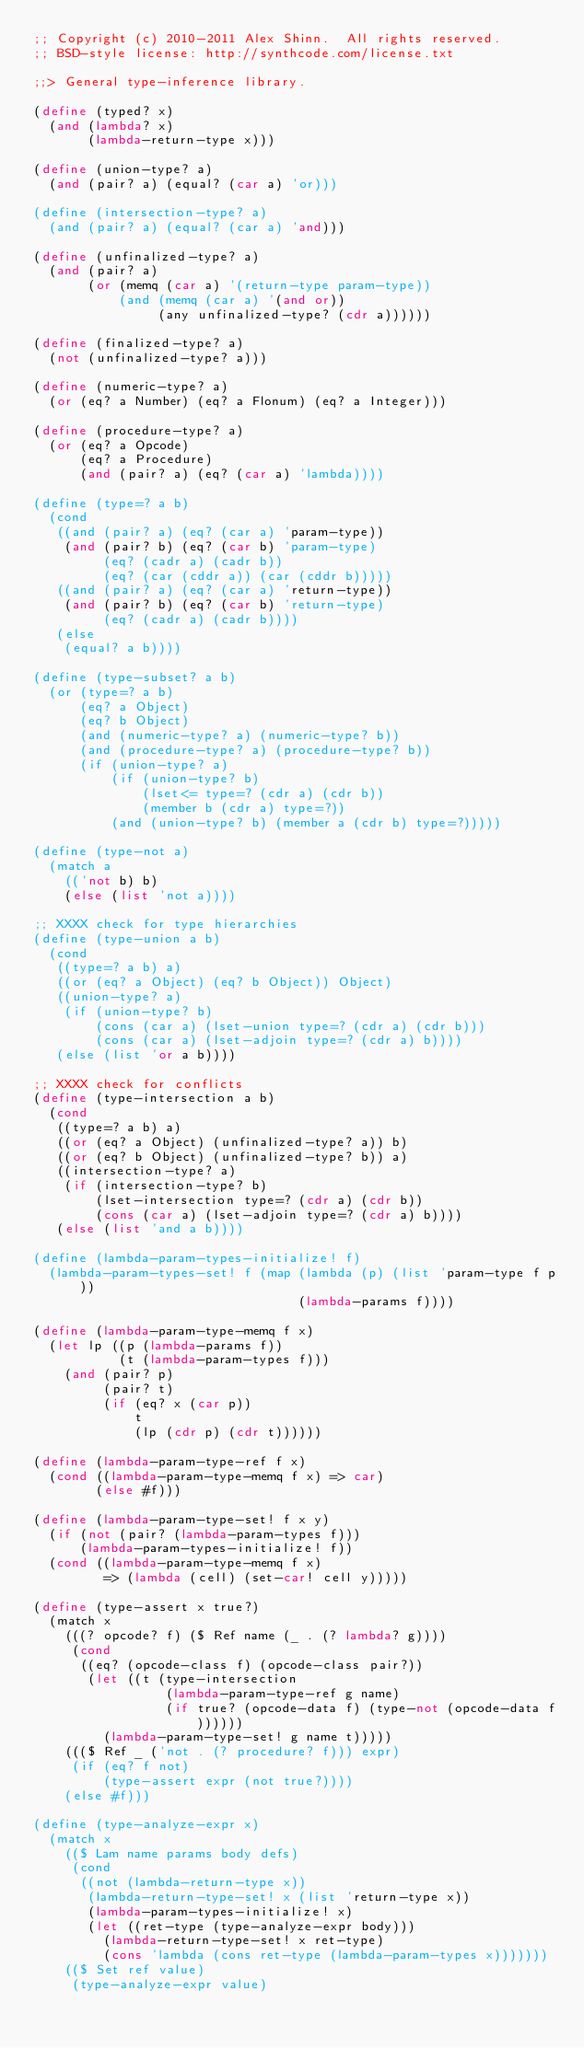Convert code to text. <code><loc_0><loc_0><loc_500><loc_500><_Scheme_>;; Copyright (c) 2010-2011 Alex Shinn.  All rights reserved.
;; BSD-style license: http://synthcode.com/license.txt

;;> General type-inference library.

(define (typed? x)
  (and (lambda? x)
       (lambda-return-type x)))

(define (union-type? a)
  (and (pair? a) (equal? (car a) 'or)))

(define (intersection-type? a)
  (and (pair? a) (equal? (car a) 'and)))

(define (unfinalized-type? a)
  (and (pair? a)
       (or (memq (car a) '(return-type param-type))
           (and (memq (car a) '(and or))
                (any unfinalized-type? (cdr a))))))

(define (finalized-type? a)
  (not (unfinalized-type? a)))

(define (numeric-type? a)
  (or (eq? a Number) (eq? a Flonum) (eq? a Integer)))

(define (procedure-type? a)
  (or (eq? a Opcode)
      (eq? a Procedure)
      (and (pair? a) (eq? (car a) 'lambda))))

(define (type=? a b)
  (cond
   ((and (pair? a) (eq? (car a) 'param-type))
    (and (pair? b) (eq? (car b) 'param-type)
         (eq? (cadr a) (cadr b))
         (eq? (car (cddr a)) (car (cddr b)))))
   ((and (pair? a) (eq? (car a) 'return-type))
    (and (pair? b) (eq? (car b) 'return-type)
         (eq? (cadr a) (cadr b))))
   (else
    (equal? a b))))

(define (type-subset? a b)
  (or (type=? a b)
      (eq? a Object)
      (eq? b Object)
      (and (numeric-type? a) (numeric-type? b))
      (and (procedure-type? a) (procedure-type? b))
      (if (union-type? a)
          (if (union-type? b)
              (lset<= type=? (cdr a) (cdr b))
              (member b (cdr a) type=?))
          (and (union-type? b) (member a (cdr b) type=?)))))

(define (type-not a)
  (match a
    (('not b) b)
    (else (list 'not a))))

;; XXXX check for type hierarchies
(define (type-union a b)
  (cond
   ((type=? a b) a)
   ((or (eq? a Object) (eq? b Object)) Object)
   ((union-type? a)
    (if (union-type? b)
        (cons (car a) (lset-union type=? (cdr a) (cdr b)))
        (cons (car a) (lset-adjoin type=? (cdr a) b))))
   (else (list 'or a b))))

;; XXXX check for conflicts
(define (type-intersection a b)
  (cond
   ((type=? a b) a)
   ((or (eq? a Object) (unfinalized-type? a)) b)
   ((or (eq? b Object) (unfinalized-type? b)) a)
   ((intersection-type? a)
    (if (intersection-type? b)
        (lset-intersection type=? (cdr a) (cdr b))
        (cons (car a) (lset-adjoin type=? (cdr a) b))))
   (else (list 'and a b))))

(define (lambda-param-types-initialize! f)
  (lambda-param-types-set! f (map (lambda (p) (list 'param-type f p))
                                  (lambda-params f))))

(define (lambda-param-type-memq f x)
  (let lp ((p (lambda-params f))
           (t (lambda-param-types f)))
    (and (pair? p)
         (pair? t)
         (if (eq? x (car p))
             t
             (lp (cdr p) (cdr t))))))

(define (lambda-param-type-ref f x)
  (cond ((lambda-param-type-memq f x) => car)
        (else #f)))

(define (lambda-param-type-set! f x y)
  (if (not (pair? (lambda-param-types f)))
      (lambda-param-types-initialize! f))
  (cond ((lambda-param-type-memq f x)
         => (lambda (cell) (set-car! cell y)))))

(define (type-assert x true?)
  (match x
    (((? opcode? f) ($ Ref name (_ . (? lambda? g))))
     (cond
      ((eq? (opcode-class f) (opcode-class pair?))
       (let ((t (type-intersection
                 (lambda-param-type-ref g name)
                 (if true? (opcode-data f) (type-not (opcode-data f))))))
         (lambda-param-type-set! g name t)))))
    ((($ Ref _ ('not . (? procedure? f))) expr)
     (if (eq? f not)
         (type-assert expr (not true?))))
    (else #f)))

(define (type-analyze-expr x)
  (match x
    (($ Lam name params body defs)
     (cond
      ((not (lambda-return-type x))
       (lambda-return-type-set! x (list 'return-type x))
       (lambda-param-types-initialize! x)
       (let ((ret-type (type-analyze-expr body)))
         (lambda-return-type-set! x ret-type)
         (cons 'lambda (cons ret-type (lambda-param-types x)))))))
    (($ Set ref value)
     (type-analyze-expr value)</code> 